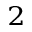<formula> <loc_0><loc_0><loc_500><loc_500>^ { 2 }</formula> 